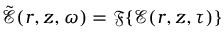Convert formula to latex. <formula><loc_0><loc_0><loc_500><loc_500>\tilde { \mathcal { E } } ( r , z , \omega ) = \mathfrak { F } \{ \mathcal { E } ( r , z , \tau ) \}</formula> 